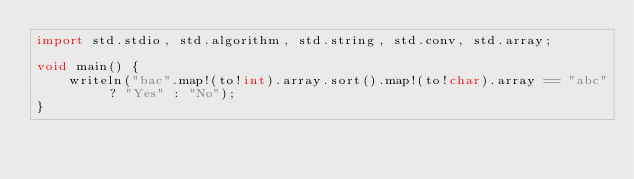<code> <loc_0><loc_0><loc_500><loc_500><_D_>import std.stdio, std.algorithm, std.string, std.conv, std.array;

void main() {
    writeln("bac".map!(to!int).array.sort().map!(to!char).array == "abc" ? "Yes" : "No");
}
</code> 